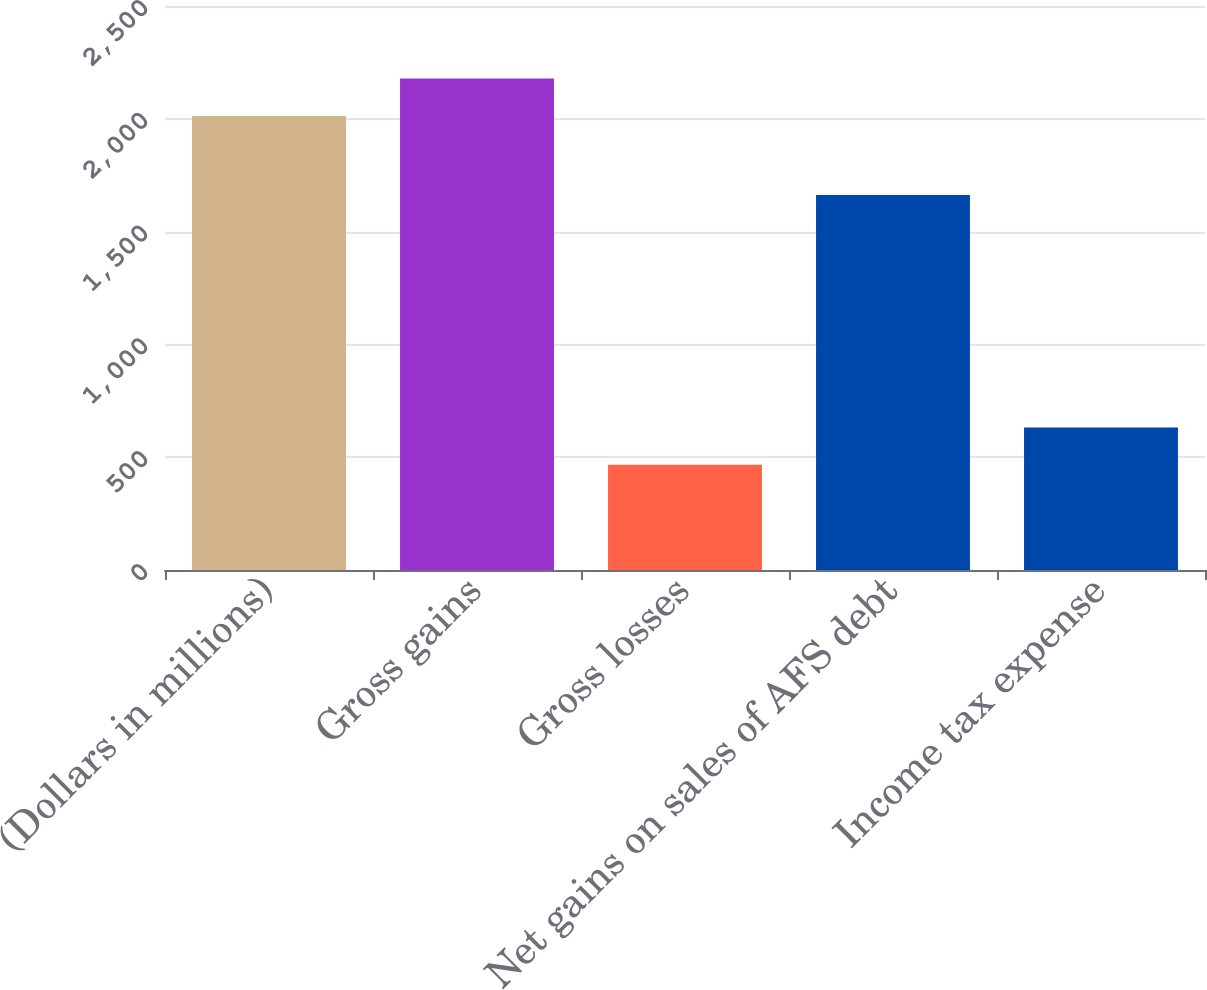<chart> <loc_0><loc_0><loc_500><loc_500><bar_chart><fcel>(Dollars in millions)<fcel>Gross gains<fcel>Gross losses<fcel>Net gains on sales of AFS debt<fcel>Income tax expense<nl><fcel>2012<fcel>2178.2<fcel>466<fcel>1662<fcel>632.2<nl></chart> 